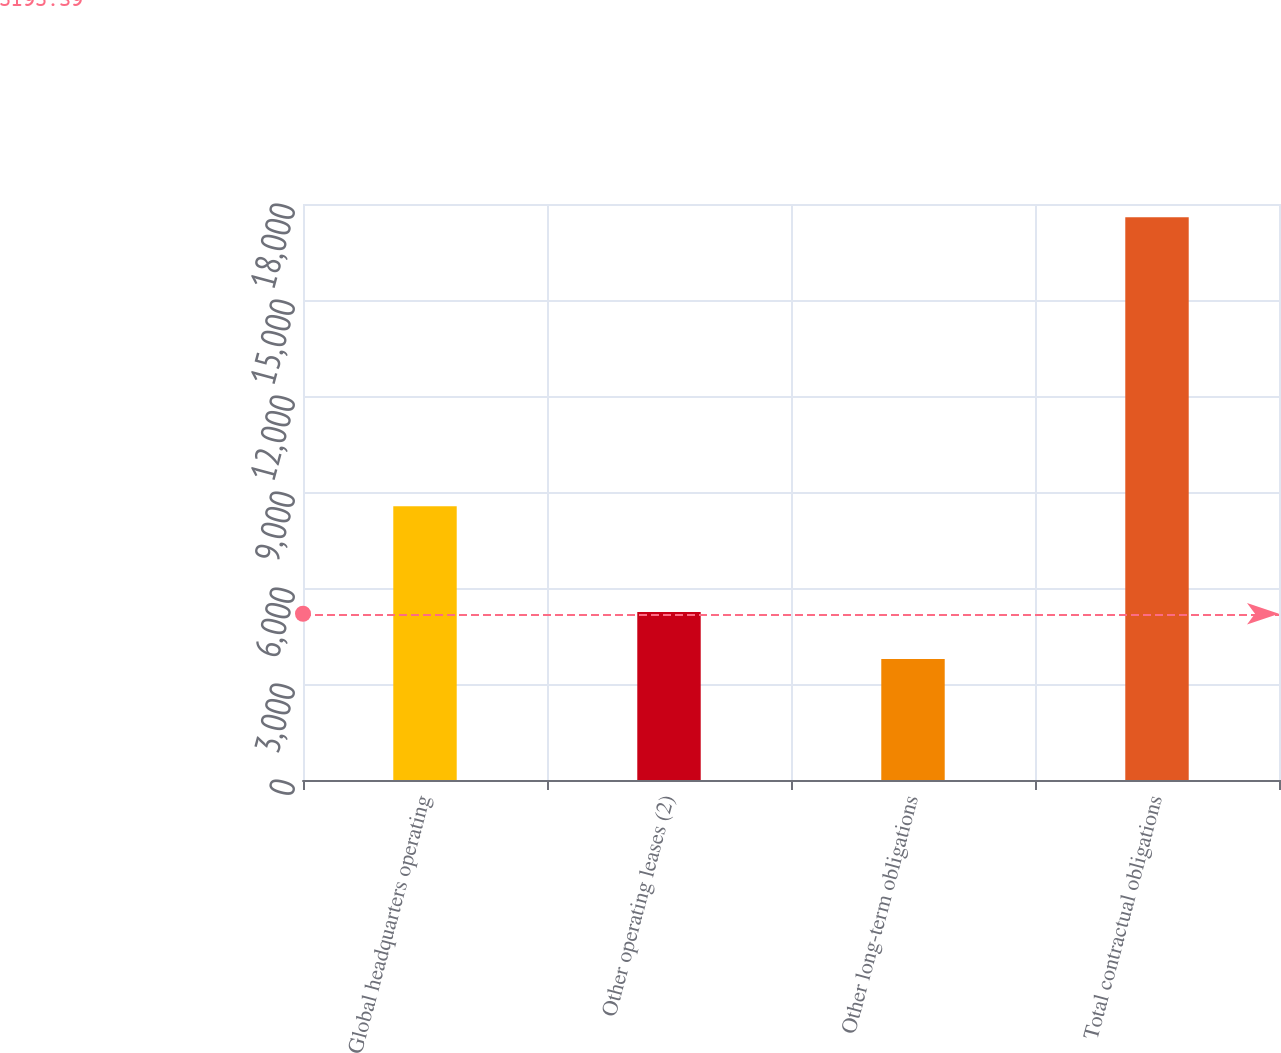Convert chart to OTSL. <chart><loc_0><loc_0><loc_500><loc_500><bar_chart><fcel>Global headquarters operating<fcel>Other operating leases (2)<fcel>Other long-term obligations<fcel>Total contractual obligations<nl><fcel>8556<fcel>5249<fcel>3780<fcel>17585<nl></chart> 